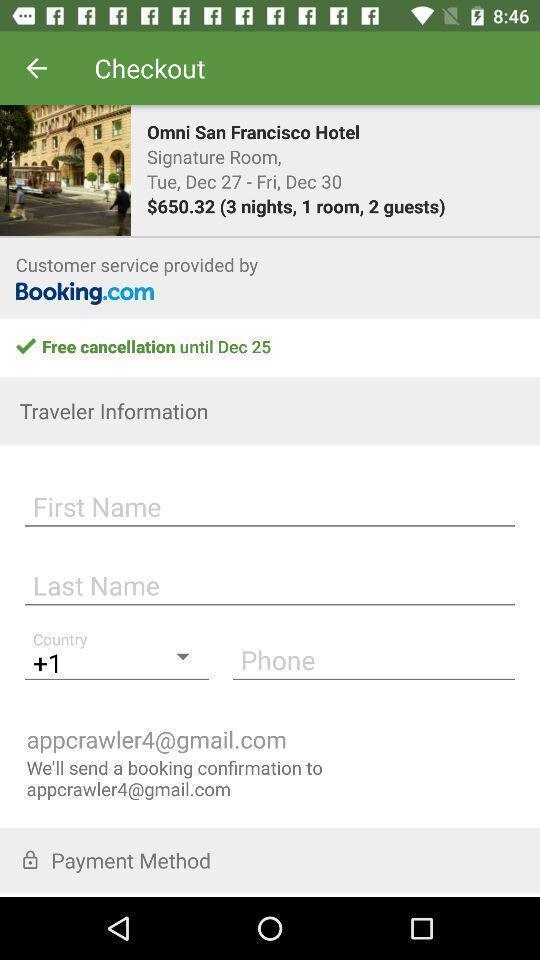Describe the key features of this screenshot. Page shows the enter user details on travel app. 